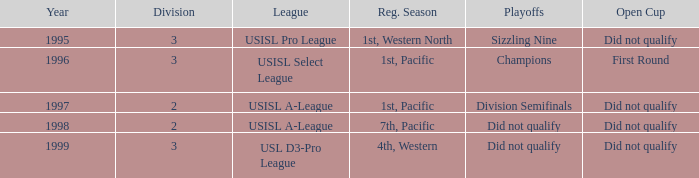How many years was there a team that was part of the usisl pro league? 1.0. 